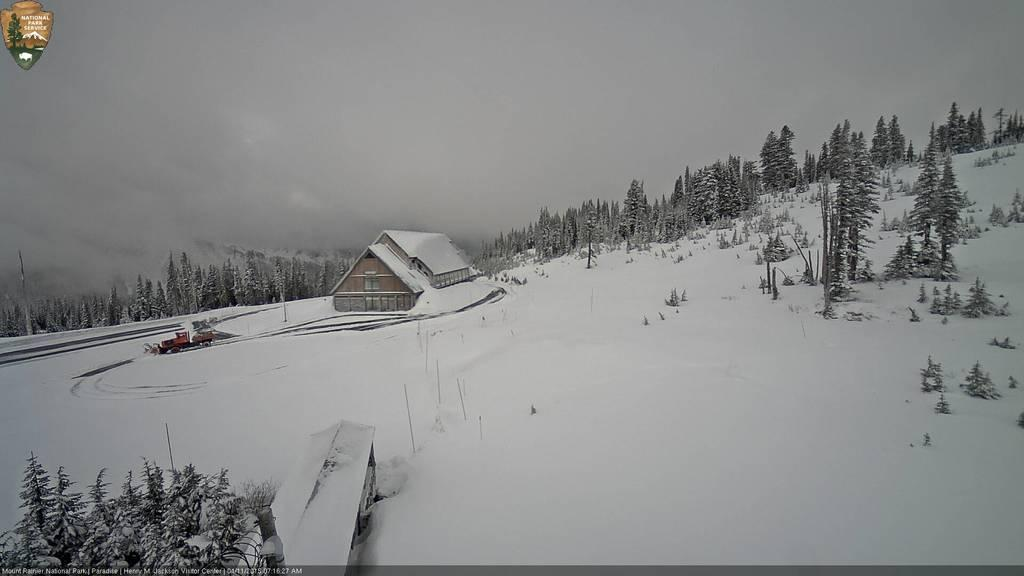What structure is located on the left side of the image? There is a house on the left side of the image. How is the house affected by the weather in the image? The house is covered with snow, indicating that it is affected by the snowy weather. What type of vegetation can be seen in the image? There are trees in the image. What is the overall condition of the environment in the image? Snow is present around the area of the image, suggesting a cold and snowy environment. What type of disease is affecting the trees in the image? There is no indication of any disease affecting the trees in the image; they appear to be healthy and covered in snow. 